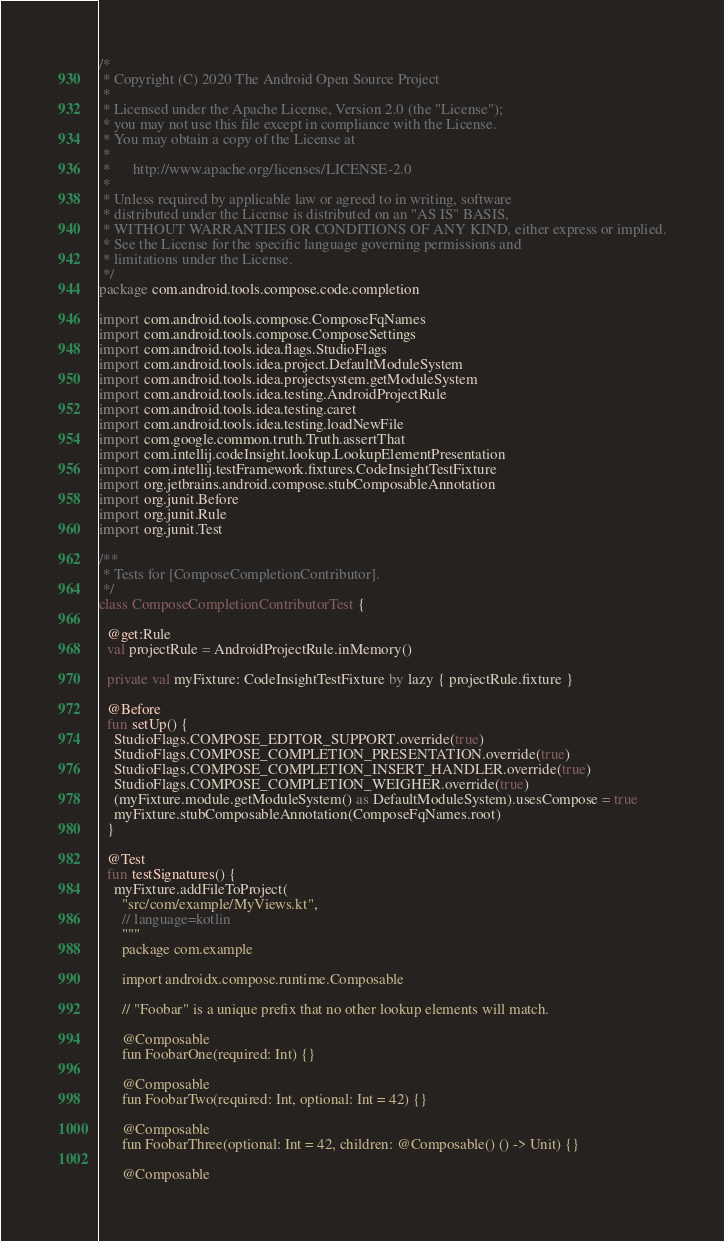<code> <loc_0><loc_0><loc_500><loc_500><_Kotlin_>/*
 * Copyright (C) 2020 The Android Open Source Project
 *
 * Licensed under the Apache License, Version 2.0 (the "License");
 * you may not use this file except in compliance with the License.
 * You may obtain a copy of the License at
 *
 *      http://www.apache.org/licenses/LICENSE-2.0
 *
 * Unless required by applicable law or agreed to in writing, software
 * distributed under the License is distributed on an "AS IS" BASIS,
 * WITHOUT WARRANTIES OR CONDITIONS OF ANY KIND, either express or implied.
 * See the License for the specific language governing permissions and
 * limitations under the License.
 */
package com.android.tools.compose.code.completion

import com.android.tools.compose.ComposeFqNames
import com.android.tools.compose.ComposeSettings
import com.android.tools.idea.flags.StudioFlags
import com.android.tools.idea.project.DefaultModuleSystem
import com.android.tools.idea.projectsystem.getModuleSystem
import com.android.tools.idea.testing.AndroidProjectRule
import com.android.tools.idea.testing.caret
import com.android.tools.idea.testing.loadNewFile
import com.google.common.truth.Truth.assertThat
import com.intellij.codeInsight.lookup.LookupElementPresentation
import com.intellij.testFramework.fixtures.CodeInsightTestFixture
import org.jetbrains.android.compose.stubComposableAnnotation
import org.junit.Before
import org.junit.Rule
import org.junit.Test

/**
 * Tests for [ComposeCompletionContributor].
 */
class ComposeCompletionContributorTest {

  @get:Rule
  val projectRule = AndroidProjectRule.inMemory()

  private val myFixture: CodeInsightTestFixture by lazy { projectRule.fixture }

  @Before
  fun setUp() {
    StudioFlags.COMPOSE_EDITOR_SUPPORT.override(true)
    StudioFlags.COMPOSE_COMPLETION_PRESENTATION.override(true)
    StudioFlags.COMPOSE_COMPLETION_INSERT_HANDLER.override(true)
    StudioFlags.COMPOSE_COMPLETION_WEIGHER.override(true)
    (myFixture.module.getModuleSystem() as DefaultModuleSystem).usesCompose = true
    myFixture.stubComposableAnnotation(ComposeFqNames.root)
  }

  @Test
  fun testSignatures() {
    myFixture.addFileToProject(
      "src/com/example/MyViews.kt",
      // language=kotlin
      """
      package com.example

      import androidx.compose.runtime.Composable

      // "Foobar" is a unique prefix that no other lookup elements will match.

      @Composable
      fun FoobarOne(required: Int) {}

      @Composable
      fun FoobarTwo(required: Int, optional: Int = 42) {}

      @Composable
      fun FoobarThree(optional: Int = 42, children: @Composable() () -> Unit) {}

      @Composable</code> 